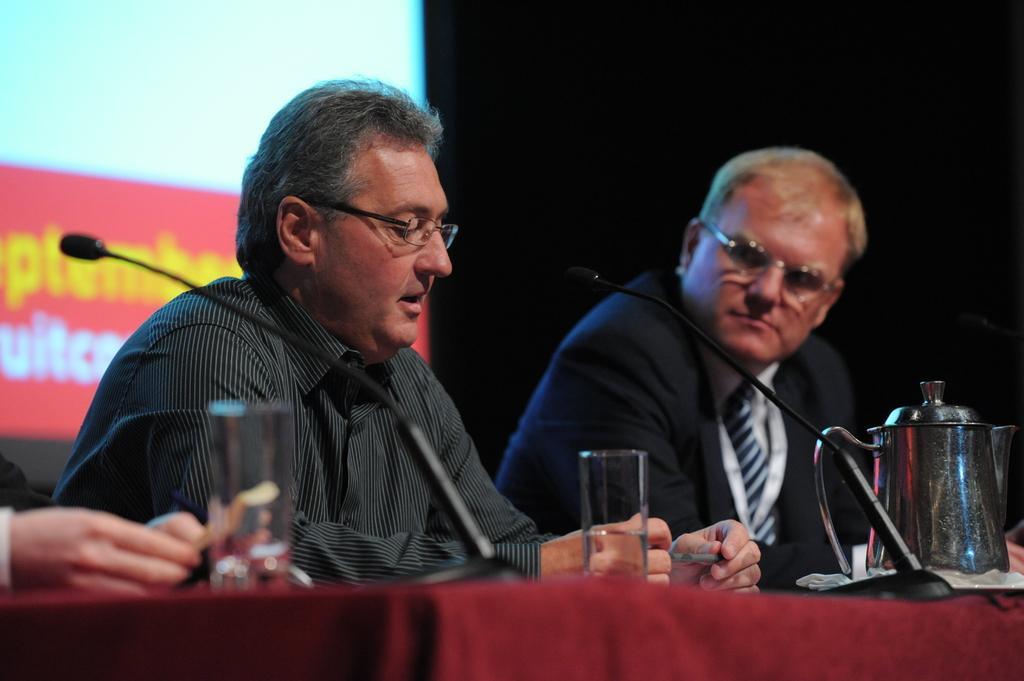In one or two sentences, can you explain what this image depicts? There are two people sitting over here and this is a table,we have two two glasses on the table with water and this is a jug. There is a microphone on the table. In the background we can see a screen. 